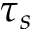Convert formula to latex. <formula><loc_0><loc_0><loc_500><loc_500>\tau _ { s }</formula> 